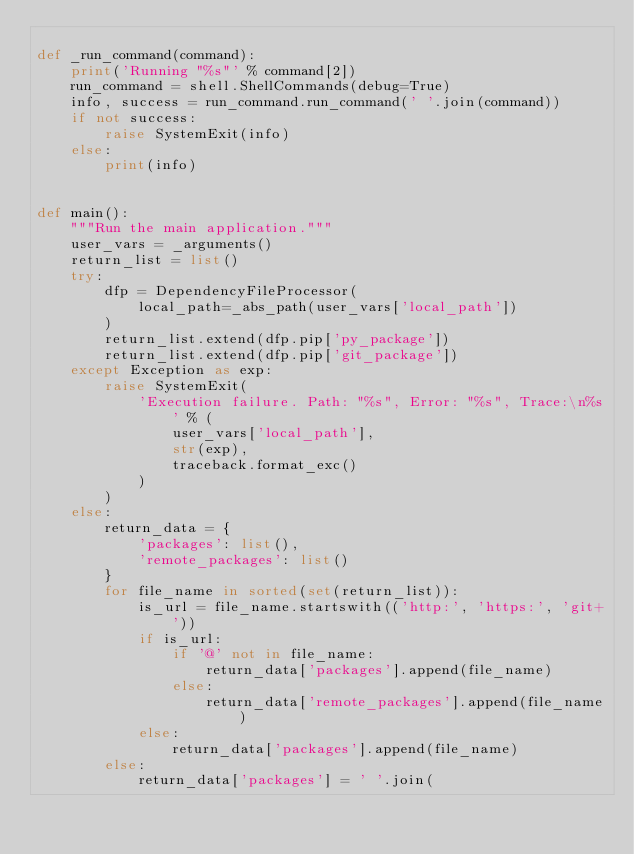<code> <loc_0><loc_0><loc_500><loc_500><_Python_>
def _run_command(command):
    print('Running "%s"' % command[2])
    run_command = shell.ShellCommands(debug=True)
    info, success = run_command.run_command(' '.join(command))
    if not success:
        raise SystemExit(info)
    else:
        print(info)


def main():
    """Run the main application."""
    user_vars = _arguments()
    return_list = list()
    try:
        dfp = DependencyFileProcessor(
            local_path=_abs_path(user_vars['local_path'])
        )
        return_list.extend(dfp.pip['py_package'])
        return_list.extend(dfp.pip['git_package'])
    except Exception as exp:
        raise SystemExit(
            'Execution failure. Path: "%s", Error: "%s", Trace:\n%s' % (
                user_vars['local_path'],
                str(exp),
                traceback.format_exc()
            )
        )
    else:
        return_data = {
            'packages': list(),
            'remote_packages': list()
        }
        for file_name in sorted(set(return_list)):
            is_url = file_name.startswith(('http:', 'https:', 'git+'))
            if is_url:
                if '@' not in file_name:
                    return_data['packages'].append(file_name)
                else:
                    return_data['remote_packages'].append(file_name)
            else:
                return_data['packages'].append(file_name)
        else:
            return_data['packages'] = ' '.join(</code> 